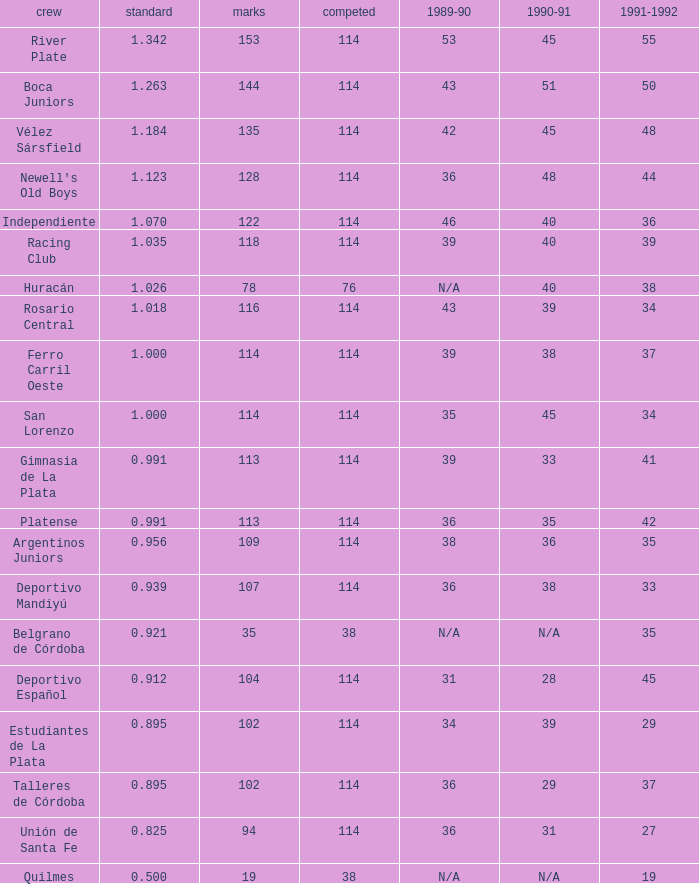How much 1991-1992 has a Team of gimnasia de la plata, and more than 113 points? 0.0. 